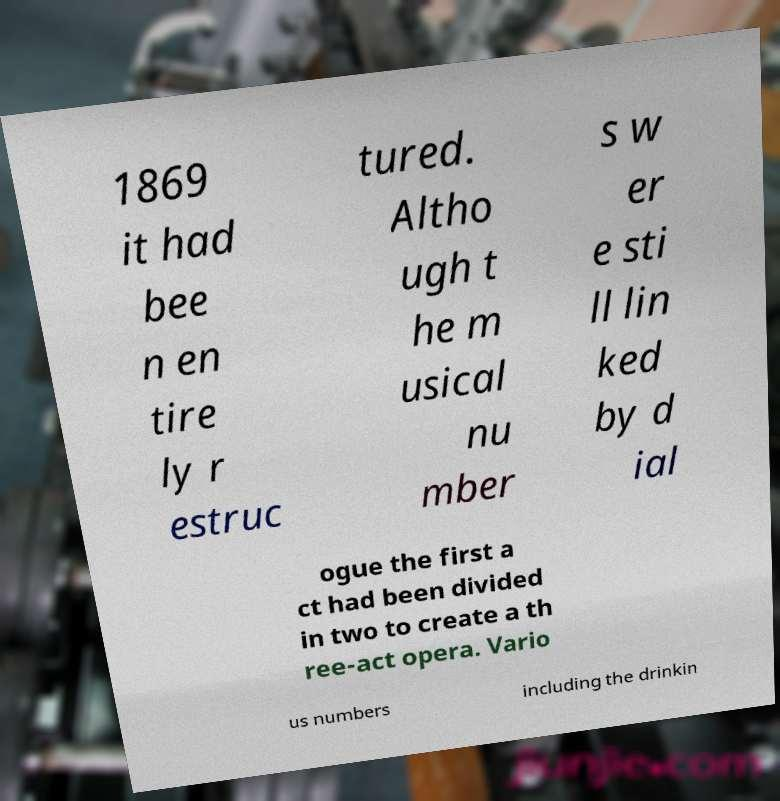Can you accurately transcribe the text from the provided image for me? 1869 it had bee n en tire ly r estruc tured. Altho ugh t he m usical nu mber s w er e sti ll lin ked by d ial ogue the first a ct had been divided in two to create a th ree-act opera. Vario us numbers including the drinkin 